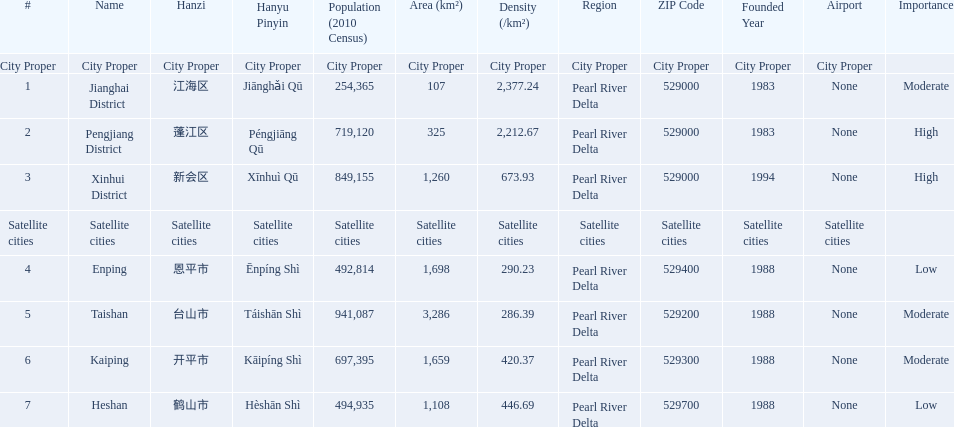What are all of the satellite cities? Enping, Taishan, Kaiping, Heshan. Of these, which has the highest population? Taishan. 